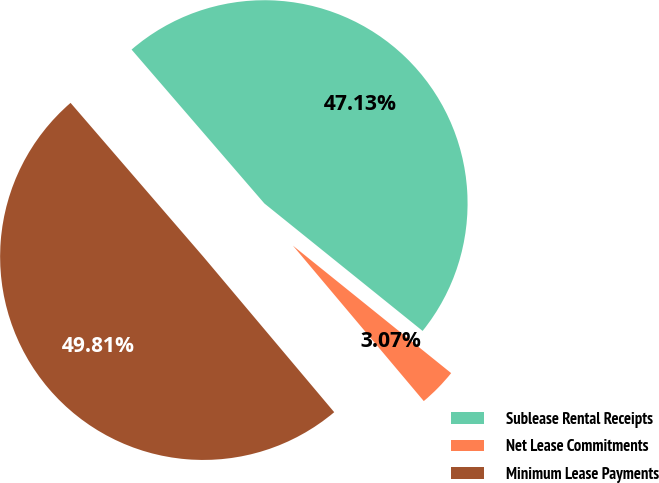Convert chart. <chart><loc_0><loc_0><loc_500><loc_500><pie_chart><fcel>Sublease Rental Receipts<fcel>Net Lease Commitments<fcel>Minimum Lease Payments<nl><fcel>47.13%<fcel>3.07%<fcel>49.81%<nl></chart> 